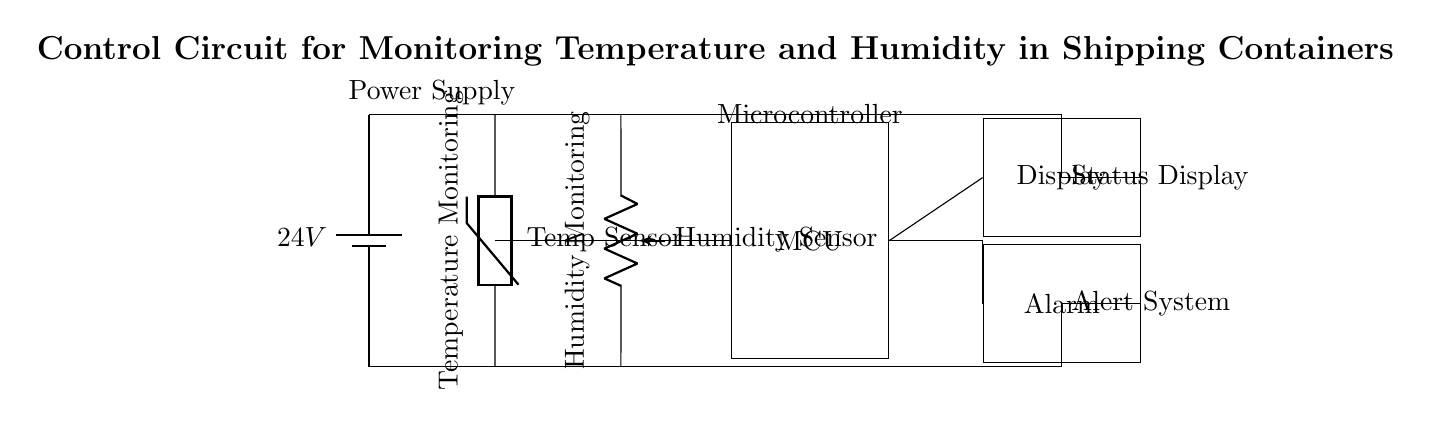What is the power supply voltage? The voltage provided by the battery in the circuit is noted as 24V, which is clearly labeled next to the battery symbol.
Answer: 24V What components are used for environmental monitoring? The circuit features a temperature sensor (thermistor) and a humidity sensor (pR), both of which are explicitly labeled in the diagram.
Answer: Temperature sensor and humidity sensor What does the MCU do in this circuit? The microcontroller (MCU) gathers data from the temperature and humidity sensors, processes it, and communicates the status to the display and alarm. It is the central processing unit of the control circuit.
Answer: Processes data What type of output does the circuit provide for alerts? The circuit shows an alarm component that signals when certain conditions (like critical temperature or humidity levels) are met, indicating it provides an alert output.
Answer: Alert system How are the sensors connected to the MCU? The sensors are connected by direct lines to the MCU, indicating that their data output feeds into the MCU for processing. The connections are shown as lines leading directly from each sensor to the MCU's side.
Answer: Direct connections What happens if the temperature or humidity exceeds safe limits? If either the temperature or humidity exceeds predefined thresholds, the MCU activates the alarm system to alert the personnel, according to the intended function of the components.
Answer: Activates alarm What is the purpose of the display in this circuit? The display serves to show the current status of temperature and humidity levels, providing real-time monitoring information to users visually.
Answer: Status display 